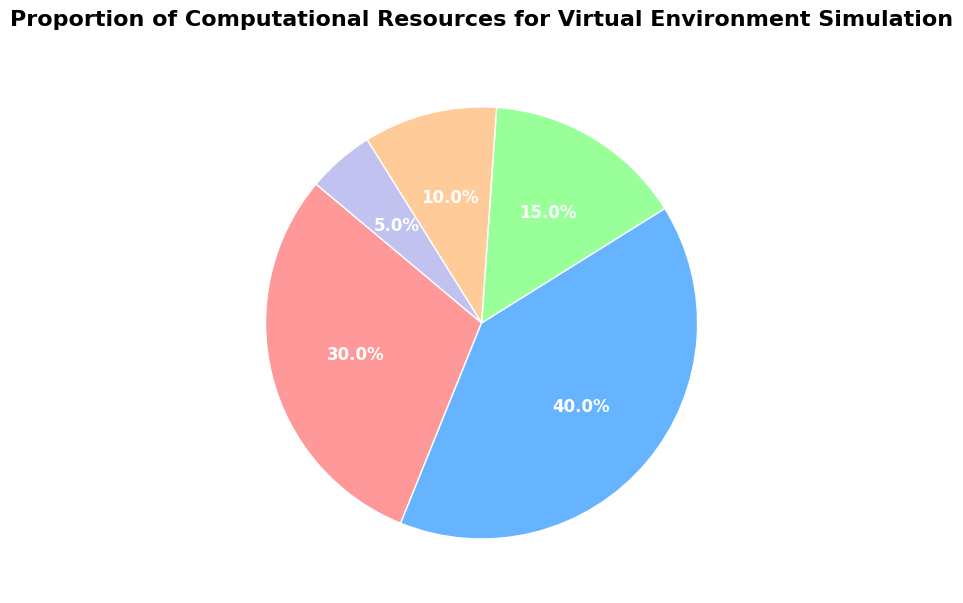Which aspect uses the largest proportion of computational resources? "Graphics Rendering" has the largest slice in the pie chart, which means it uses the largest proportion of computational resources.
Answer: Graphics Rendering Which two aspects combined use more than 50% of the computational resources? Combining the percentages of "Physics Engine" (30%) and "Graphics Rendering" (40%) yields 70%, which is more than 50%.
Answer: Physics Engine and Graphics Rendering What is the proportion of computational resources allocated to AI Behavior compared to Audio Processing? The portion for AI Behavior is 15%, while the portion for Audio Processing is 10%. AI Behavior uses more resources.
Answer: AI Behavior uses more resources How much more computational resources are allocated to Graphics Rendering than Networking? Graphics Rendering uses 40%, and Networking uses 5%. The difference is 40% - 5% = 35%.
Answer: 35% If you sum the resources for Audio Processing and Networking, what is the total percentage? The sum of percentages for Audio Processing (10%) and Networking (5%) is 10% + 5% = 15%.
Answer: 15% Which aspect uses the smallest proportion of computational resources? "Networking" has the smallest slice in the pie chart, representing the smallest proportion of computational resources.
Answer: Networking What is the combined proportion of resources used by Physics Engine, AI Behavior, and Audio Processing? Adding the percentages for Physics Engine (30%), AI Behavior (15%), and Audio Processing (10%) gives 30% + 15% + 10% = 55%.
Answer: 55% What is the ratio of resources allocated to Graphics Rendering to those allocated to AI Behavior? Graphics Rendering uses 40%, and AI Behavior uses 15%. The ratio is 40:15, which simplifies to approximately 8:3.
Answer: 8:3 